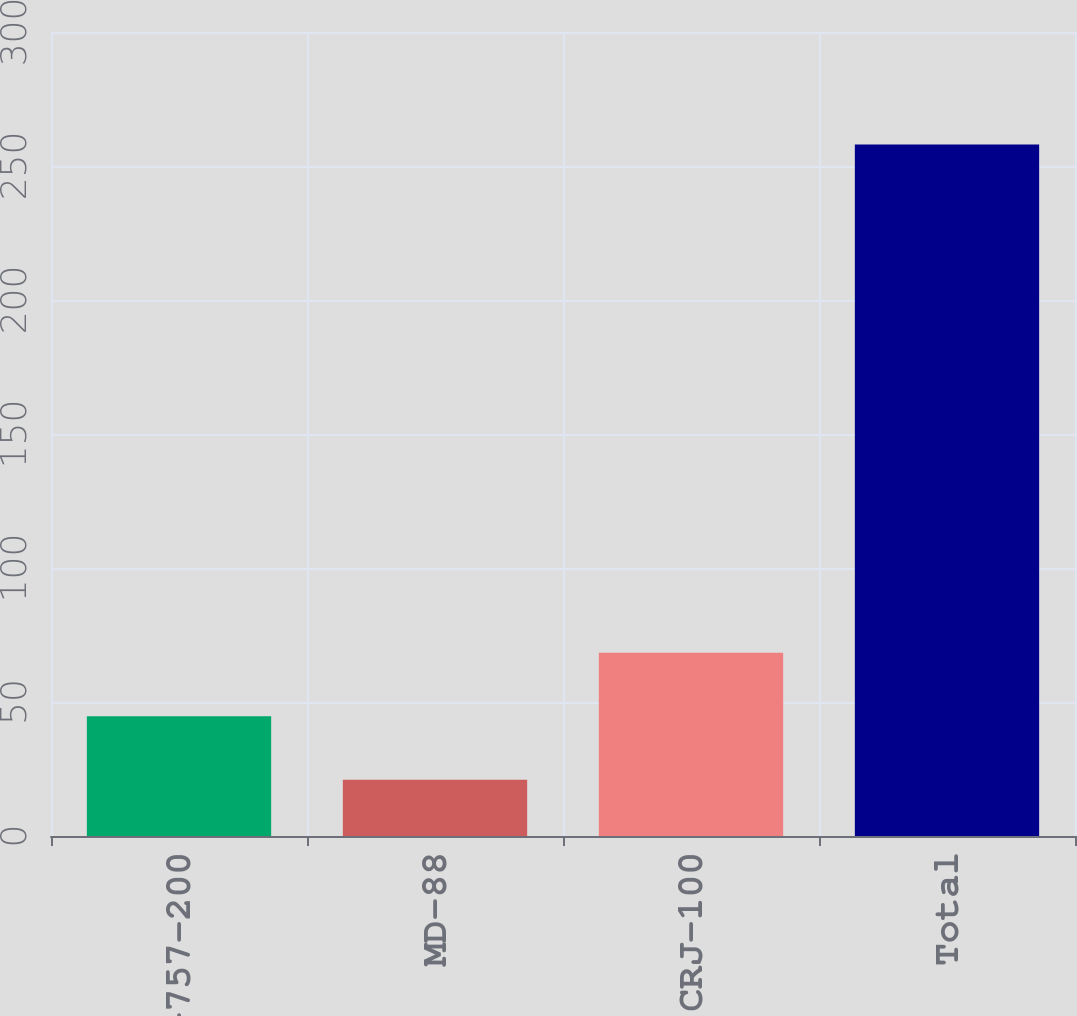Convert chart to OTSL. <chart><loc_0><loc_0><loc_500><loc_500><bar_chart><fcel>B-757-200<fcel>MD-88<fcel>CRJ-100<fcel>Total<nl><fcel>44.7<fcel>21<fcel>68.4<fcel>258<nl></chart> 